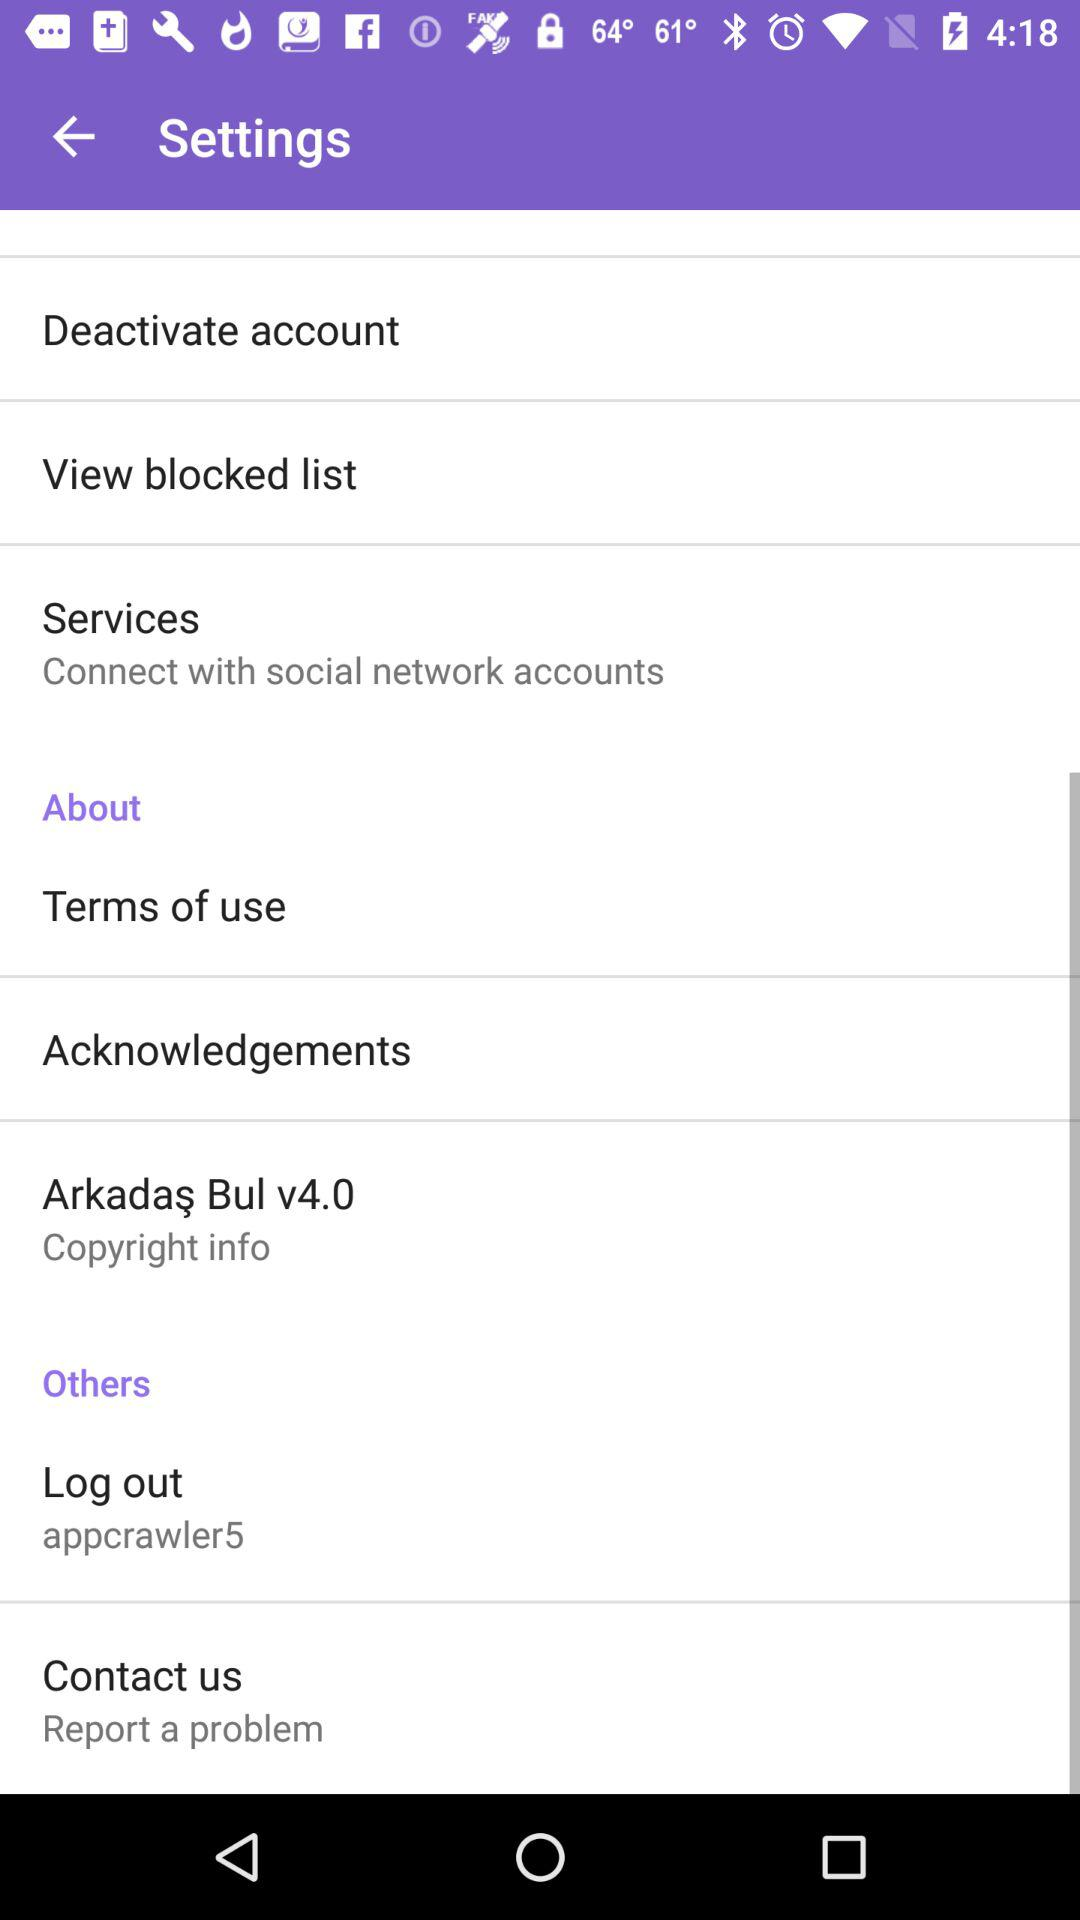What is the version? The version is v4.0. 